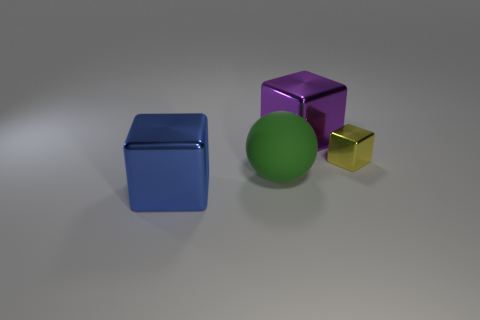Subtract all big blocks. How many blocks are left? 1 Add 2 tiny red rubber cubes. How many objects exist? 6 Subtract all cubes. How many objects are left? 1 Subtract all tiny red matte spheres. Subtract all blocks. How many objects are left? 1 Add 4 tiny blocks. How many tiny blocks are left? 5 Add 1 gray metal balls. How many gray metal balls exist? 1 Subtract 0 blue cylinders. How many objects are left? 4 